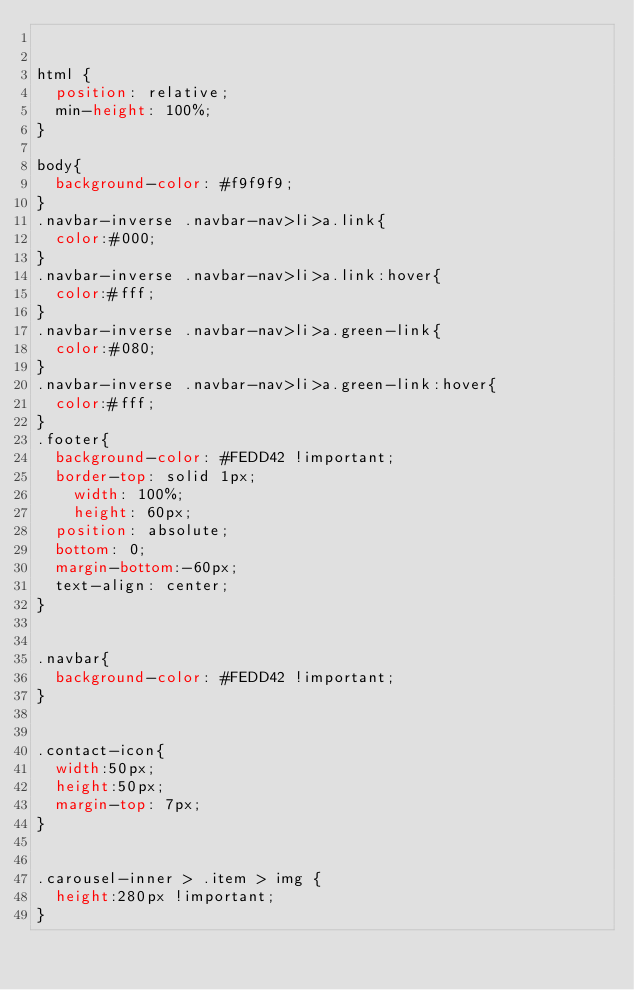<code> <loc_0><loc_0><loc_500><loc_500><_CSS_>

html {
  position: relative;
  min-height: 100%;
}

body{
	background-color: #f9f9f9;
}
.navbar-inverse .navbar-nav>li>a.link{
	color:#000;
}
.navbar-inverse .navbar-nav>li>a.link:hover{
	color:#fff;
}
.navbar-inverse .navbar-nav>li>a.green-link{
	color:#080;
}
.navbar-inverse .navbar-nav>li>a.green-link:hover{
	color:#fff;
}
.footer{
	background-color: #FEDD42 !important;
	border-top: solid 1px;
    width: 100%;
    height: 60px;
	position: absolute;
	bottom: 0;
	margin-bottom:-60px;
	text-align: center;
}


.navbar{
	background-color: #FEDD42 !important;
}


.contact-icon{
	width:50px;
	height:50px;
	margin-top: 7px;
}


.carousel-inner > .item > img {
  height:280px !important;
}</code> 